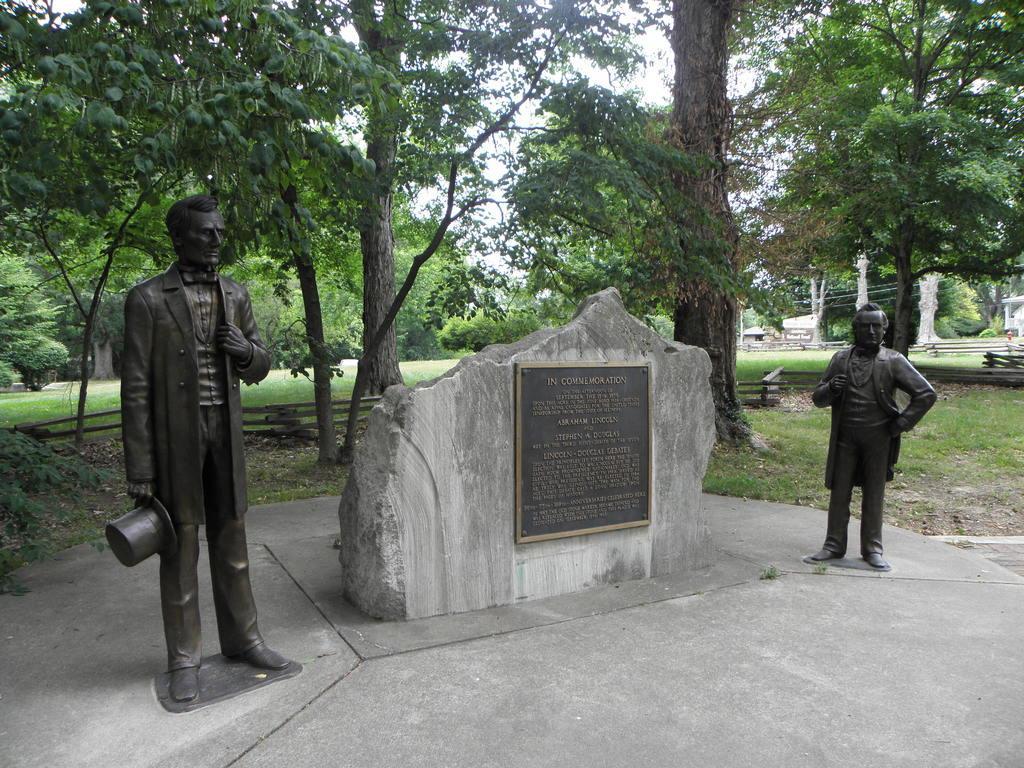Can you describe this image briefly? In the image we can see two sculptures of persons standing, wearing clothes. Here we can see the broken stone sheet. On it there is a board. Here we can see grass, trees, fence and white sky. 